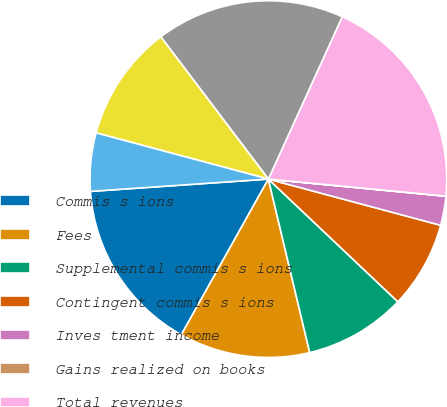Convert chart. <chart><loc_0><loc_0><loc_500><loc_500><pie_chart><fcel>Commis s ions<fcel>Fees<fcel>Supplemental commis s ions<fcel>Contingent commis s ions<fcel>Inves tment income<fcel>Gains realized on books<fcel>Total revenues<fcel>Compens ation<fcel>Operating<fcel>Depreciation<nl><fcel>15.79%<fcel>11.84%<fcel>9.21%<fcel>7.9%<fcel>2.64%<fcel>0.01%<fcel>19.73%<fcel>17.1%<fcel>10.53%<fcel>5.27%<nl></chart> 